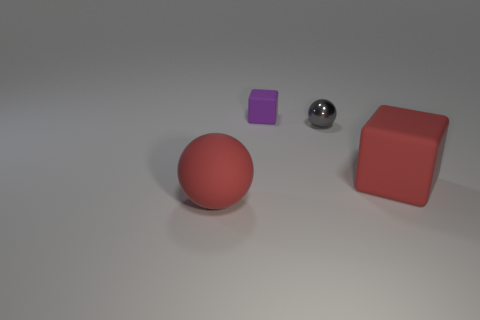What is the shape of the big matte object that is the same color as the matte sphere?
Give a very brief answer. Cube. The small ball has what color?
Offer a terse response. Gray. Is there a purple rubber object in front of the big red sphere left of the big block?
Your answer should be very brief. No. What number of green things have the same size as the metallic sphere?
Your answer should be compact. 0. What number of tiny gray shiny objects are left of the large red rubber thing to the right of the ball right of the small rubber thing?
Your answer should be compact. 1. What number of objects are both in front of the gray thing and right of the small purple object?
Keep it short and to the point. 1. Are there any other things that are the same color as the big block?
Make the answer very short. Yes. What number of shiny objects are either tiny gray balls or big red spheres?
Make the answer very short. 1. There is a sphere that is in front of the red object that is right of the sphere that is behind the red cube; what is it made of?
Give a very brief answer. Rubber. The big object that is left of the matte block to the right of the small gray metallic object is made of what material?
Provide a succinct answer. Rubber. 